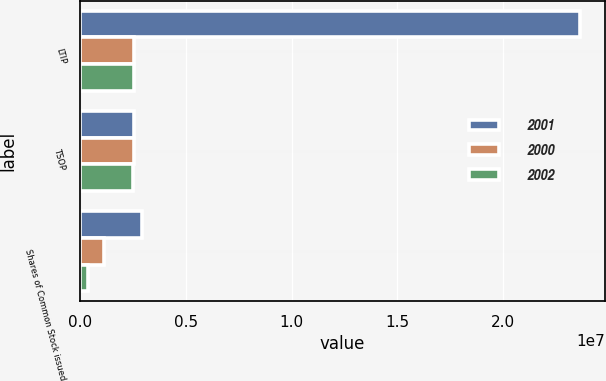<chart> <loc_0><loc_0><loc_500><loc_500><stacked_bar_chart><ecel><fcel>LTIP<fcel>TSOP<fcel>Shares of Common Stock issued<nl><fcel>2001<fcel>2.36451e+07<fcel>2.5682e+06<fcel>2.9179e+06<nl><fcel>2000<fcel>2.54479e+06<fcel>2.535e+06<fcel>1.14635e+06<nl><fcel>2002<fcel>2.55458e+06<fcel>2.4887e+06<fcel>395626<nl></chart> 